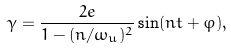<formula> <loc_0><loc_0><loc_500><loc_500>\gamma = \frac { 2 e } { 1 - ( n / \omega _ { u } ) ^ { 2 } } \sin ( n t + \varphi ) ,</formula> 